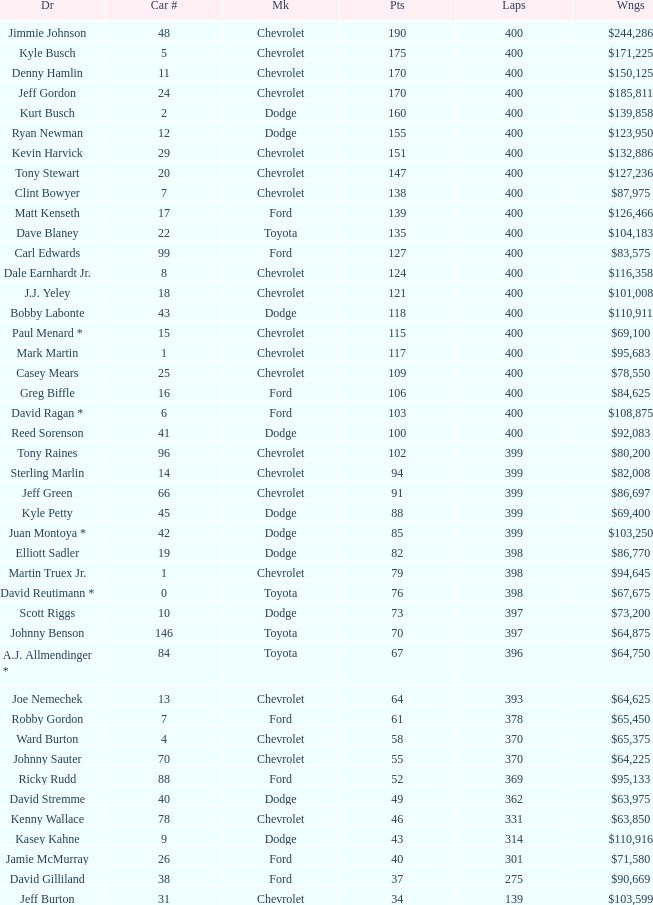What is the make of car 31? Chevrolet. 